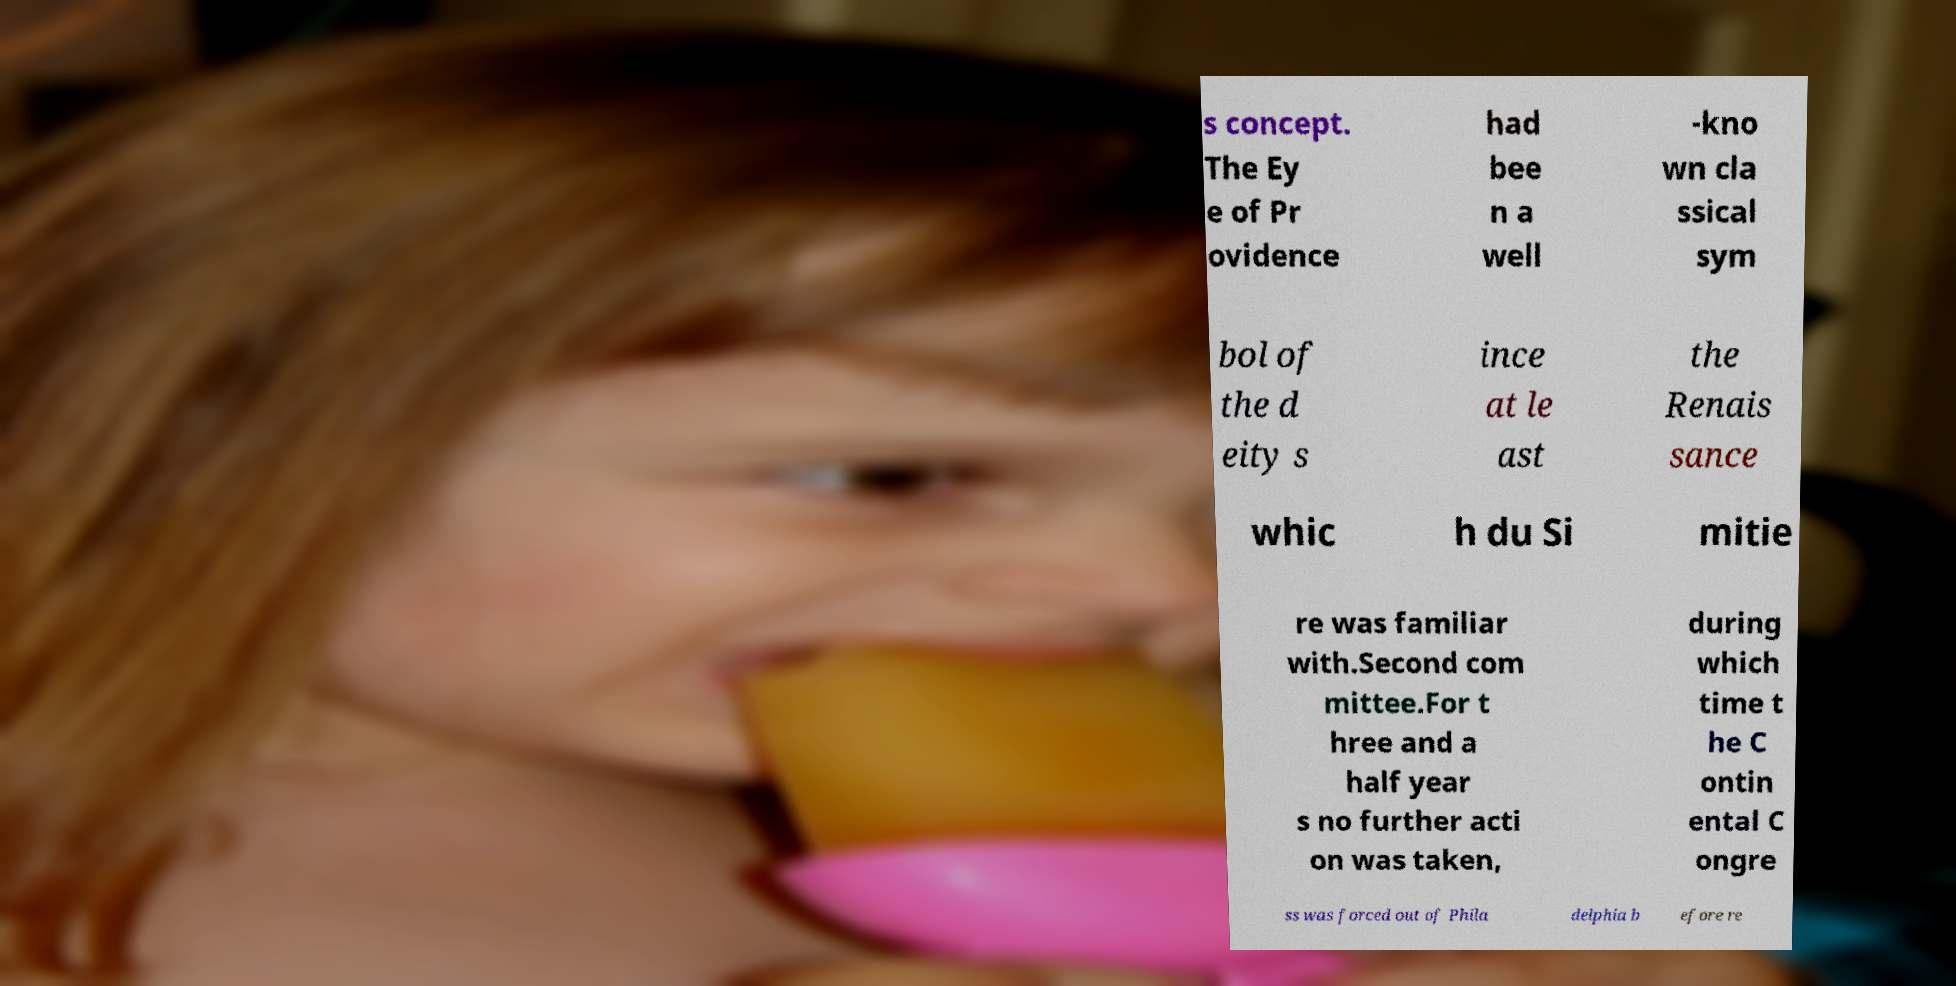Please identify and transcribe the text found in this image. s concept. The Ey e of Pr ovidence had bee n a well -kno wn cla ssical sym bol of the d eity s ince at le ast the Renais sance whic h du Si mitie re was familiar with.Second com mittee.For t hree and a half year s no further acti on was taken, during which time t he C ontin ental C ongre ss was forced out of Phila delphia b efore re 